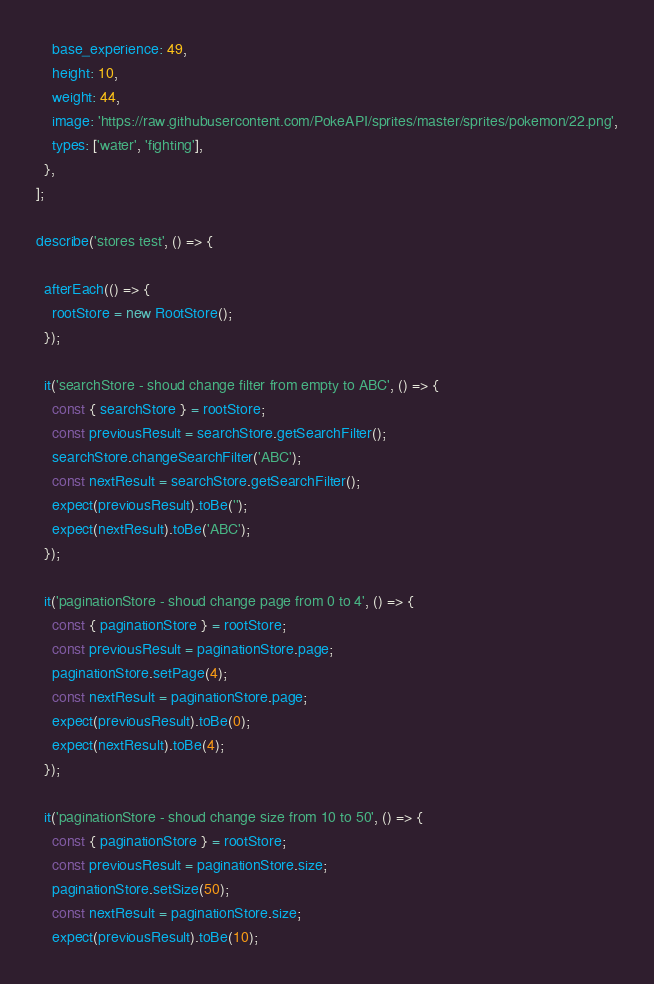Convert code to text. <code><loc_0><loc_0><loc_500><loc_500><_TypeScript_>    base_experience: 49,
    height: 10,
    weight: 44,
    image: 'https://raw.githubusercontent.com/PokeAPI/sprites/master/sprites/pokemon/22.png',
    types: ['water', 'fighting'],
  },
];

describe('stores test', () => {

  afterEach(() => {
    rootStore = new RootStore();
  });

  it('searchStore - shoud change filter from empty to ABC', () => {
    const { searchStore } = rootStore;
    const previousResult = searchStore.getSearchFilter();
    searchStore.changeSearchFilter('ABC');
    const nextResult = searchStore.getSearchFilter();
    expect(previousResult).toBe('');
    expect(nextResult).toBe('ABC');
  });

  it('paginationStore - shoud change page from 0 to 4', () => {
    const { paginationStore } = rootStore;
    const previousResult = paginationStore.page;
    paginationStore.setPage(4);
    const nextResult = paginationStore.page;
    expect(previousResult).toBe(0);
    expect(nextResult).toBe(4);
  });

  it('paginationStore - shoud change size from 10 to 50', () => {
    const { paginationStore } = rootStore;
    const previousResult = paginationStore.size;
    paginationStore.setSize(50);
    const nextResult = paginationStore.size;
    expect(previousResult).toBe(10);</code> 